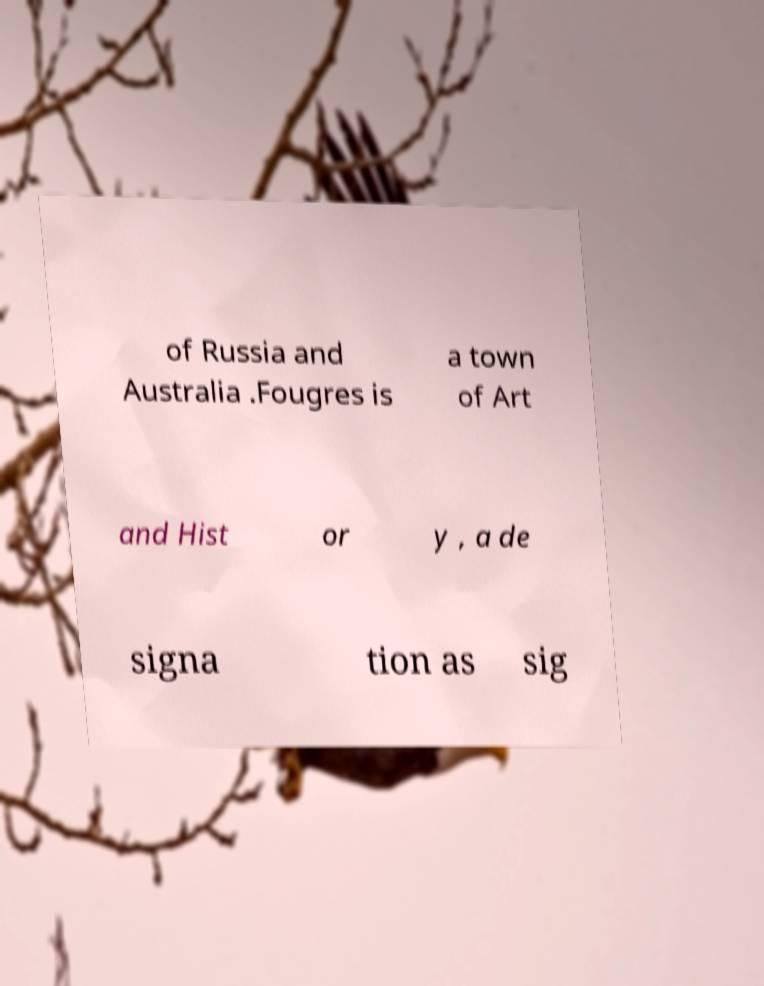There's text embedded in this image that I need extracted. Can you transcribe it verbatim? of Russia and Australia .Fougres is a town of Art and Hist or y , a de signa tion as sig 